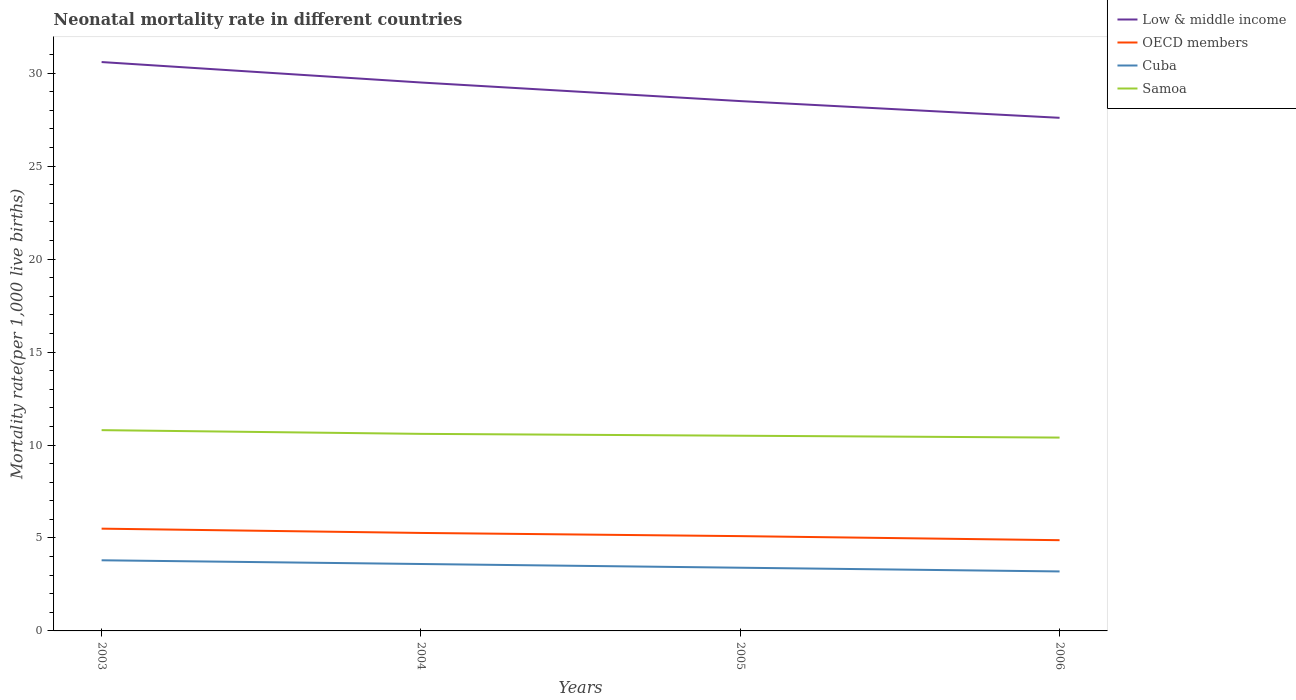How many different coloured lines are there?
Your answer should be very brief. 4. What is the total neonatal mortality rate in Samoa in the graph?
Provide a short and direct response. 0.2. What is the difference between the highest and the second highest neonatal mortality rate in OECD members?
Make the answer very short. 0.62. What is the difference between the highest and the lowest neonatal mortality rate in Samoa?
Make the answer very short. 2. Is the neonatal mortality rate in Samoa strictly greater than the neonatal mortality rate in OECD members over the years?
Ensure brevity in your answer.  No. How many years are there in the graph?
Provide a short and direct response. 4. What is the difference between two consecutive major ticks on the Y-axis?
Give a very brief answer. 5. Are the values on the major ticks of Y-axis written in scientific E-notation?
Keep it short and to the point. No. Where does the legend appear in the graph?
Offer a very short reply. Top right. How are the legend labels stacked?
Your response must be concise. Vertical. What is the title of the graph?
Ensure brevity in your answer.  Neonatal mortality rate in different countries. What is the label or title of the Y-axis?
Offer a very short reply. Mortality rate(per 1,0 live births). What is the Mortality rate(per 1,000 live births) of Low & middle income in 2003?
Your response must be concise. 30.6. What is the Mortality rate(per 1,000 live births) of OECD members in 2003?
Your answer should be very brief. 5.5. What is the Mortality rate(per 1,000 live births) of Cuba in 2003?
Your answer should be compact. 3.8. What is the Mortality rate(per 1,000 live births) in Samoa in 2003?
Give a very brief answer. 10.8. What is the Mortality rate(per 1,000 live births) of Low & middle income in 2004?
Make the answer very short. 29.5. What is the Mortality rate(per 1,000 live births) of OECD members in 2004?
Your answer should be very brief. 5.27. What is the Mortality rate(per 1,000 live births) in Cuba in 2004?
Your answer should be compact. 3.6. What is the Mortality rate(per 1,000 live births) of OECD members in 2005?
Offer a terse response. 5.1. What is the Mortality rate(per 1,000 live births) in Cuba in 2005?
Offer a terse response. 3.4. What is the Mortality rate(per 1,000 live births) of Low & middle income in 2006?
Offer a very short reply. 27.6. What is the Mortality rate(per 1,000 live births) of OECD members in 2006?
Your answer should be very brief. 4.88. What is the Mortality rate(per 1,000 live births) in Cuba in 2006?
Make the answer very short. 3.2. What is the Mortality rate(per 1,000 live births) of Samoa in 2006?
Offer a terse response. 10.4. Across all years, what is the maximum Mortality rate(per 1,000 live births) in Low & middle income?
Give a very brief answer. 30.6. Across all years, what is the maximum Mortality rate(per 1,000 live births) in OECD members?
Offer a terse response. 5.5. Across all years, what is the maximum Mortality rate(per 1,000 live births) in Cuba?
Provide a short and direct response. 3.8. Across all years, what is the maximum Mortality rate(per 1,000 live births) of Samoa?
Your response must be concise. 10.8. Across all years, what is the minimum Mortality rate(per 1,000 live births) in Low & middle income?
Offer a terse response. 27.6. Across all years, what is the minimum Mortality rate(per 1,000 live births) of OECD members?
Provide a short and direct response. 4.88. Across all years, what is the minimum Mortality rate(per 1,000 live births) of Samoa?
Ensure brevity in your answer.  10.4. What is the total Mortality rate(per 1,000 live births) of Low & middle income in the graph?
Your answer should be compact. 116.2. What is the total Mortality rate(per 1,000 live births) of OECD members in the graph?
Ensure brevity in your answer.  20.75. What is the total Mortality rate(per 1,000 live births) of Cuba in the graph?
Ensure brevity in your answer.  14. What is the total Mortality rate(per 1,000 live births) in Samoa in the graph?
Keep it short and to the point. 42.3. What is the difference between the Mortality rate(per 1,000 live births) in Low & middle income in 2003 and that in 2004?
Offer a very short reply. 1.1. What is the difference between the Mortality rate(per 1,000 live births) of OECD members in 2003 and that in 2004?
Offer a very short reply. 0.23. What is the difference between the Mortality rate(per 1,000 live births) in OECD members in 2003 and that in 2005?
Your answer should be very brief. 0.4. What is the difference between the Mortality rate(per 1,000 live births) in Cuba in 2003 and that in 2005?
Provide a short and direct response. 0.4. What is the difference between the Mortality rate(per 1,000 live births) of Samoa in 2003 and that in 2005?
Provide a short and direct response. 0.3. What is the difference between the Mortality rate(per 1,000 live births) of Low & middle income in 2003 and that in 2006?
Your response must be concise. 3. What is the difference between the Mortality rate(per 1,000 live births) in OECD members in 2003 and that in 2006?
Your response must be concise. 0.62. What is the difference between the Mortality rate(per 1,000 live births) of Cuba in 2003 and that in 2006?
Give a very brief answer. 0.6. What is the difference between the Mortality rate(per 1,000 live births) of OECD members in 2004 and that in 2005?
Provide a succinct answer. 0.17. What is the difference between the Mortality rate(per 1,000 live births) in Samoa in 2004 and that in 2005?
Your answer should be compact. 0.1. What is the difference between the Mortality rate(per 1,000 live births) in OECD members in 2004 and that in 2006?
Provide a succinct answer. 0.39. What is the difference between the Mortality rate(per 1,000 live births) in Cuba in 2004 and that in 2006?
Keep it short and to the point. 0.4. What is the difference between the Mortality rate(per 1,000 live births) of Samoa in 2004 and that in 2006?
Ensure brevity in your answer.  0.2. What is the difference between the Mortality rate(per 1,000 live births) in OECD members in 2005 and that in 2006?
Give a very brief answer. 0.22. What is the difference between the Mortality rate(per 1,000 live births) of Cuba in 2005 and that in 2006?
Your answer should be very brief. 0.2. What is the difference between the Mortality rate(per 1,000 live births) of Low & middle income in 2003 and the Mortality rate(per 1,000 live births) of OECD members in 2004?
Offer a terse response. 25.33. What is the difference between the Mortality rate(per 1,000 live births) of OECD members in 2003 and the Mortality rate(per 1,000 live births) of Cuba in 2004?
Give a very brief answer. 1.9. What is the difference between the Mortality rate(per 1,000 live births) of OECD members in 2003 and the Mortality rate(per 1,000 live births) of Samoa in 2004?
Keep it short and to the point. -5.1. What is the difference between the Mortality rate(per 1,000 live births) in Low & middle income in 2003 and the Mortality rate(per 1,000 live births) in OECD members in 2005?
Provide a short and direct response. 25.5. What is the difference between the Mortality rate(per 1,000 live births) of Low & middle income in 2003 and the Mortality rate(per 1,000 live births) of Cuba in 2005?
Your answer should be very brief. 27.2. What is the difference between the Mortality rate(per 1,000 live births) of Low & middle income in 2003 and the Mortality rate(per 1,000 live births) of Samoa in 2005?
Provide a succinct answer. 20.1. What is the difference between the Mortality rate(per 1,000 live births) in OECD members in 2003 and the Mortality rate(per 1,000 live births) in Cuba in 2005?
Your response must be concise. 2.1. What is the difference between the Mortality rate(per 1,000 live births) of OECD members in 2003 and the Mortality rate(per 1,000 live births) of Samoa in 2005?
Provide a succinct answer. -5. What is the difference between the Mortality rate(per 1,000 live births) of Low & middle income in 2003 and the Mortality rate(per 1,000 live births) of OECD members in 2006?
Ensure brevity in your answer.  25.72. What is the difference between the Mortality rate(per 1,000 live births) in Low & middle income in 2003 and the Mortality rate(per 1,000 live births) in Cuba in 2006?
Ensure brevity in your answer.  27.4. What is the difference between the Mortality rate(per 1,000 live births) in Low & middle income in 2003 and the Mortality rate(per 1,000 live births) in Samoa in 2006?
Offer a very short reply. 20.2. What is the difference between the Mortality rate(per 1,000 live births) in OECD members in 2003 and the Mortality rate(per 1,000 live births) in Cuba in 2006?
Your answer should be very brief. 2.3. What is the difference between the Mortality rate(per 1,000 live births) of OECD members in 2003 and the Mortality rate(per 1,000 live births) of Samoa in 2006?
Your answer should be compact. -4.9. What is the difference between the Mortality rate(per 1,000 live births) in Low & middle income in 2004 and the Mortality rate(per 1,000 live births) in OECD members in 2005?
Ensure brevity in your answer.  24.4. What is the difference between the Mortality rate(per 1,000 live births) of Low & middle income in 2004 and the Mortality rate(per 1,000 live births) of Cuba in 2005?
Your answer should be compact. 26.1. What is the difference between the Mortality rate(per 1,000 live births) of OECD members in 2004 and the Mortality rate(per 1,000 live births) of Cuba in 2005?
Your response must be concise. 1.87. What is the difference between the Mortality rate(per 1,000 live births) in OECD members in 2004 and the Mortality rate(per 1,000 live births) in Samoa in 2005?
Keep it short and to the point. -5.23. What is the difference between the Mortality rate(per 1,000 live births) in Low & middle income in 2004 and the Mortality rate(per 1,000 live births) in OECD members in 2006?
Your response must be concise. 24.62. What is the difference between the Mortality rate(per 1,000 live births) in Low & middle income in 2004 and the Mortality rate(per 1,000 live births) in Cuba in 2006?
Ensure brevity in your answer.  26.3. What is the difference between the Mortality rate(per 1,000 live births) in OECD members in 2004 and the Mortality rate(per 1,000 live births) in Cuba in 2006?
Make the answer very short. 2.07. What is the difference between the Mortality rate(per 1,000 live births) in OECD members in 2004 and the Mortality rate(per 1,000 live births) in Samoa in 2006?
Your answer should be very brief. -5.13. What is the difference between the Mortality rate(per 1,000 live births) in Cuba in 2004 and the Mortality rate(per 1,000 live births) in Samoa in 2006?
Keep it short and to the point. -6.8. What is the difference between the Mortality rate(per 1,000 live births) in Low & middle income in 2005 and the Mortality rate(per 1,000 live births) in OECD members in 2006?
Offer a very short reply. 23.62. What is the difference between the Mortality rate(per 1,000 live births) in Low & middle income in 2005 and the Mortality rate(per 1,000 live births) in Cuba in 2006?
Provide a succinct answer. 25.3. What is the difference between the Mortality rate(per 1,000 live births) in Low & middle income in 2005 and the Mortality rate(per 1,000 live births) in Samoa in 2006?
Your answer should be compact. 18.1. What is the difference between the Mortality rate(per 1,000 live births) of OECD members in 2005 and the Mortality rate(per 1,000 live births) of Cuba in 2006?
Your answer should be compact. 1.9. What is the difference between the Mortality rate(per 1,000 live births) of OECD members in 2005 and the Mortality rate(per 1,000 live births) of Samoa in 2006?
Provide a short and direct response. -5.3. What is the difference between the Mortality rate(per 1,000 live births) in Cuba in 2005 and the Mortality rate(per 1,000 live births) in Samoa in 2006?
Make the answer very short. -7. What is the average Mortality rate(per 1,000 live births) in Low & middle income per year?
Ensure brevity in your answer.  29.05. What is the average Mortality rate(per 1,000 live births) of OECD members per year?
Give a very brief answer. 5.19. What is the average Mortality rate(per 1,000 live births) of Cuba per year?
Ensure brevity in your answer.  3.5. What is the average Mortality rate(per 1,000 live births) of Samoa per year?
Offer a very short reply. 10.57. In the year 2003, what is the difference between the Mortality rate(per 1,000 live births) in Low & middle income and Mortality rate(per 1,000 live births) in OECD members?
Ensure brevity in your answer.  25.1. In the year 2003, what is the difference between the Mortality rate(per 1,000 live births) in Low & middle income and Mortality rate(per 1,000 live births) in Cuba?
Offer a terse response. 26.8. In the year 2003, what is the difference between the Mortality rate(per 1,000 live births) in Low & middle income and Mortality rate(per 1,000 live births) in Samoa?
Provide a short and direct response. 19.8. In the year 2003, what is the difference between the Mortality rate(per 1,000 live births) of OECD members and Mortality rate(per 1,000 live births) of Cuba?
Keep it short and to the point. 1.7. In the year 2003, what is the difference between the Mortality rate(per 1,000 live births) of OECD members and Mortality rate(per 1,000 live births) of Samoa?
Keep it short and to the point. -5.3. In the year 2003, what is the difference between the Mortality rate(per 1,000 live births) in Cuba and Mortality rate(per 1,000 live births) in Samoa?
Your answer should be compact. -7. In the year 2004, what is the difference between the Mortality rate(per 1,000 live births) of Low & middle income and Mortality rate(per 1,000 live births) of OECD members?
Provide a short and direct response. 24.23. In the year 2004, what is the difference between the Mortality rate(per 1,000 live births) of Low & middle income and Mortality rate(per 1,000 live births) of Cuba?
Your answer should be compact. 25.9. In the year 2004, what is the difference between the Mortality rate(per 1,000 live births) of Low & middle income and Mortality rate(per 1,000 live births) of Samoa?
Your answer should be very brief. 18.9. In the year 2004, what is the difference between the Mortality rate(per 1,000 live births) in OECD members and Mortality rate(per 1,000 live births) in Cuba?
Keep it short and to the point. 1.67. In the year 2004, what is the difference between the Mortality rate(per 1,000 live births) of OECD members and Mortality rate(per 1,000 live births) of Samoa?
Your answer should be compact. -5.33. In the year 2004, what is the difference between the Mortality rate(per 1,000 live births) of Cuba and Mortality rate(per 1,000 live births) of Samoa?
Provide a short and direct response. -7. In the year 2005, what is the difference between the Mortality rate(per 1,000 live births) of Low & middle income and Mortality rate(per 1,000 live births) of OECD members?
Make the answer very short. 23.4. In the year 2005, what is the difference between the Mortality rate(per 1,000 live births) in Low & middle income and Mortality rate(per 1,000 live births) in Cuba?
Give a very brief answer. 25.1. In the year 2005, what is the difference between the Mortality rate(per 1,000 live births) in OECD members and Mortality rate(per 1,000 live births) in Cuba?
Provide a succinct answer. 1.7. In the year 2005, what is the difference between the Mortality rate(per 1,000 live births) of OECD members and Mortality rate(per 1,000 live births) of Samoa?
Offer a terse response. -5.4. In the year 2006, what is the difference between the Mortality rate(per 1,000 live births) in Low & middle income and Mortality rate(per 1,000 live births) in OECD members?
Keep it short and to the point. 22.72. In the year 2006, what is the difference between the Mortality rate(per 1,000 live births) in Low & middle income and Mortality rate(per 1,000 live births) in Cuba?
Give a very brief answer. 24.4. In the year 2006, what is the difference between the Mortality rate(per 1,000 live births) in OECD members and Mortality rate(per 1,000 live births) in Cuba?
Ensure brevity in your answer.  1.68. In the year 2006, what is the difference between the Mortality rate(per 1,000 live births) in OECD members and Mortality rate(per 1,000 live births) in Samoa?
Make the answer very short. -5.52. What is the ratio of the Mortality rate(per 1,000 live births) in Low & middle income in 2003 to that in 2004?
Provide a succinct answer. 1.04. What is the ratio of the Mortality rate(per 1,000 live births) in OECD members in 2003 to that in 2004?
Provide a short and direct response. 1.04. What is the ratio of the Mortality rate(per 1,000 live births) in Cuba in 2003 to that in 2004?
Offer a terse response. 1.06. What is the ratio of the Mortality rate(per 1,000 live births) of Samoa in 2003 to that in 2004?
Your response must be concise. 1.02. What is the ratio of the Mortality rate(per 1,000 live births) in Low & middle income in 2003 to that in 2005?
Offer a terse response. 1.07. What is the ratio of the Mortality rate(per 1,000 live births) of OECD members in 2003 to that in 2005?
Provide a succinct answer. 1.08. What is the ratio of the Mortality rate(per 1,000 live births) of Cuba in 2003 to that in 2005?
Keep it short and to the point. 1.12. What is the ratio of the Mortality rate(per 1,000 live births) in Samoa in 2003 to that in 2005?
Your answer should be very brief. 1.03. What is the ratio of the Mortality rate(per 1,000 live births) of Low & middle income in 2003 to that in 2006?
Your response must be concise. 1.11. What is the ratio of the Mortality rate(per 1,000 live births) of OECD members in 2003 to that in 2006?
Your answer should be very brief. 1.13. What is the ratio of the Mortality rate(per 1,000 live births) in Cuba in 2003 to that in 2006?
Provide a short and direct response. 1.19. What is the ratio of the Mortality rate(per 1,000 live births) of Samoa in 2003 to that in 2006?
Keep it short and to the point. 1.04. What is the ratio of the Mortality rate(per 1,000 live births) of Low & middle income in 2004 to that in 2005?
Your answer should be compact. 1.04. What is the ratio of the Mortality rate(per 1,000 live births) in OECD members in 2004 to that in 2005?
Your answer should be very brief. 1.03. What is the ratio of the Mortality rate(per 1,000 live births) of Cuba in 2004 to that in 2005?
Ensure brevity in your answer.  1.06. What is the ratio of the Mortality rate(per 1,000 live births) of Samoa in 2004 to that in 2005?
Make the answer very short. 1.01. What is the ratio of the Mortality rate(per 1,000 live births) of Low & middle income in 2004 to that in 2006?
Keep it short and to the point. 1.07. What is the ratio of the Mortality rate(per 1,000 live births) in OECD members in 2004 to that in 2006?
Your answer should be very brief. 1.08. What is the ratio of the Mortality rate(per 1,000 live births) in Samoa in 2004 to that in 2006?
Make the answer very short. 1.02. What is the ratio of the Mortality rate(per 1,000 live births) of Low & middle income in 2005 to that in 2006?
Provide a succinct answer. 1.03. What is the ratio of the Mortality rate(per 1,000 live births) of OECD members in 2005 to that in 2006?
Keep it short and to the point. 1.04. What is the ratio of the Mortality rate(per 1,000 live births) of Samoa in 2005 to that in 2006?
Your answer should be very brief. 1.01. What is the difference between the highest and the second highest Mortality rate(per 1,000 live births) of Low & middle income?
Provide a short and direct response. 1.1. What is the difference between the highest and the second highest Mortality rate(per 1,000 live births) of OECD members?
Offer a terse response. 0.23. What is the difference between the highest and the lowest Mortality rate(per 1,000 live births) of Low & middle income?
Your answer should be compact. 3. What is the difference between the highest and the lowest Mortality rate(per 1,000 live births) of OECD members?
Ensure brevity in your answer.  0.62. 